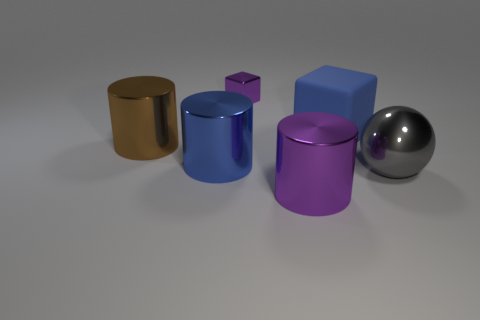Subtract all large purple shiny cylinders. How many cylinders are left? 2 Subtract all spheres. How many objects are left? 5 Add 1 large blue blocks. How many objects exist? 7 Subtract 1 blue cylinders. How many objects are left? 5 Subtract all brown cubes. Subtract all brown spheres. How many cubes are left? 2 Subtract all tiny blue cubes. Subtract all small purple objects. How many objects are left? 5 Add 2 blue rubber things. How many blue rubber things are left? 3 Add 1 blue rubber blocks. How many blue rubber blocks exist? 2 